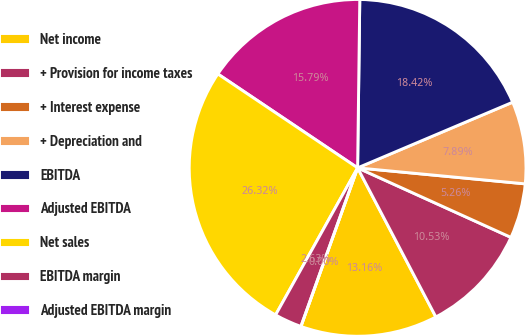Convert chart to OTSL. <chart><loc_0><loc_0><loc_500><loc_500><pie_chart><fcel>Net income<fcel>+ Provision for income taxes<fcel>+ Interest expense<fcel>+ Depreciation and<fcel>EBITDA<fcel>Adjusted EBITDA<fcel>Net sales<fcel>EBITDA margin<fcel>Adjusted EBITDA margin<nl><fcel>13.16%<fcel>10.53%<fcel>5.26%<fcel>7.89%<fcel>18.42%<fcel>15.79%<fcel>26.32%<fcel>2.63%<fcel>0.0%<nl></chart> 